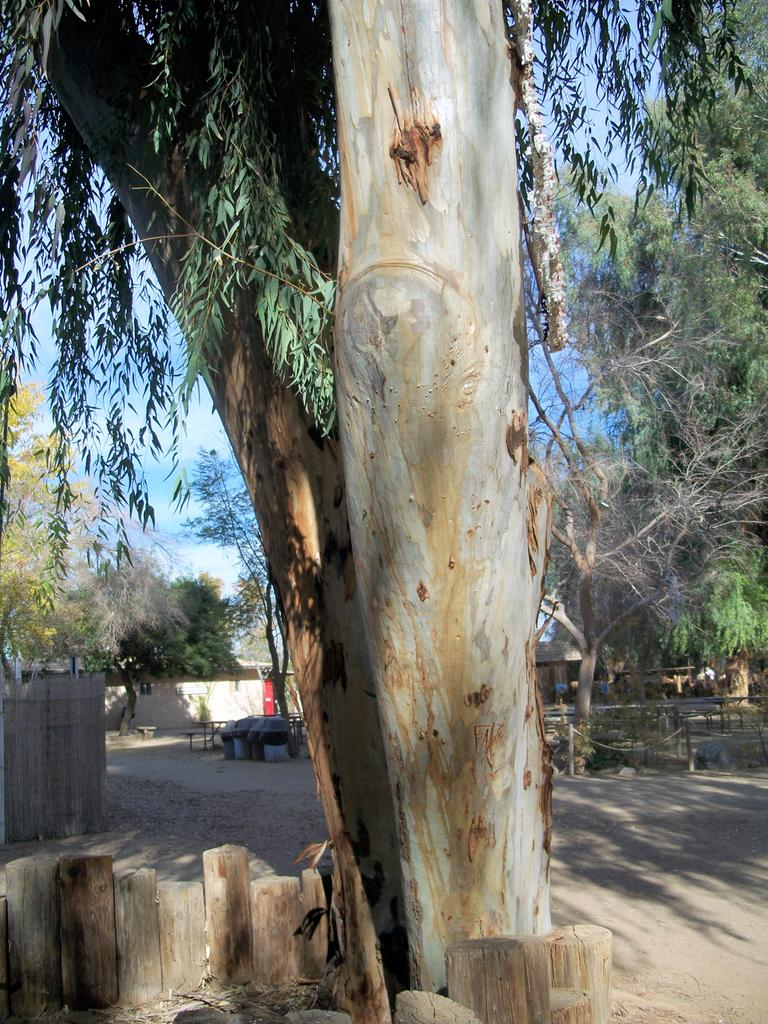What objects can be seen in the foreground of the image? There are small wooden poles and a tree in the foreground of the image. What else is visible in the foreground besides the wooden poles and tree? There are no other objects visible in the foreground. What can be seen in the background of the image? There are trees, houses, and the sky visible in the background of the image. How many cacti are present in the image? There are no cacti present in the image. What unit of measurement is used to determine the height of the chair in the image? There is no chair present in the image, so no unit of measurement is needed. 